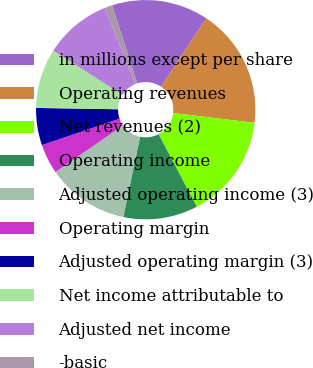<chart> <loc_0><loc_0><loc_500><loc_500><pie_chart><fcel>in millions except per share<fcel>Operating revenues<fcel>Net revenues (2)<fcel>Operating income<fcel>Adjusted operating income (3)<fcel>Operating margin<fcel>Adjusted operating margin (3)<fcel>Net income attributable to<fcel>Adjusted net income<fcel>-basic<nl><fcel>14.29%<fcel>17.58%<fcel>15.38%<fcel>10.99%<fcel>12.09%<fcel>4.4%<fcel>5.49%<fcel>8.79%<fcel>9.89%<fcel>1.1%<nl></chart> 